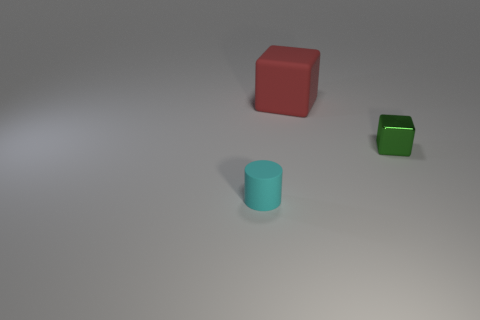Add 2 big gray rubber balls. How many objects exist? 5 Subtract all blocks. How many objects are left? 1 Subtract 0 blue cubes. How many objects are left? 3 Subtract 1 cylinders. How many cylinders are left? 0 Subtract all purple blocks. Subtract all gray spheres. How many blocks are left? 2 Subtract all yellow cylinders. How many green blocks are left? 1 Subtract all tiny green objects. Subtract all cylinders. How many objects are left? 1 Add 2 tiny cubes. How many tiny cubes are left? 3 Add 2 small metallic cubes. How many small metallic cubes exist? 3 